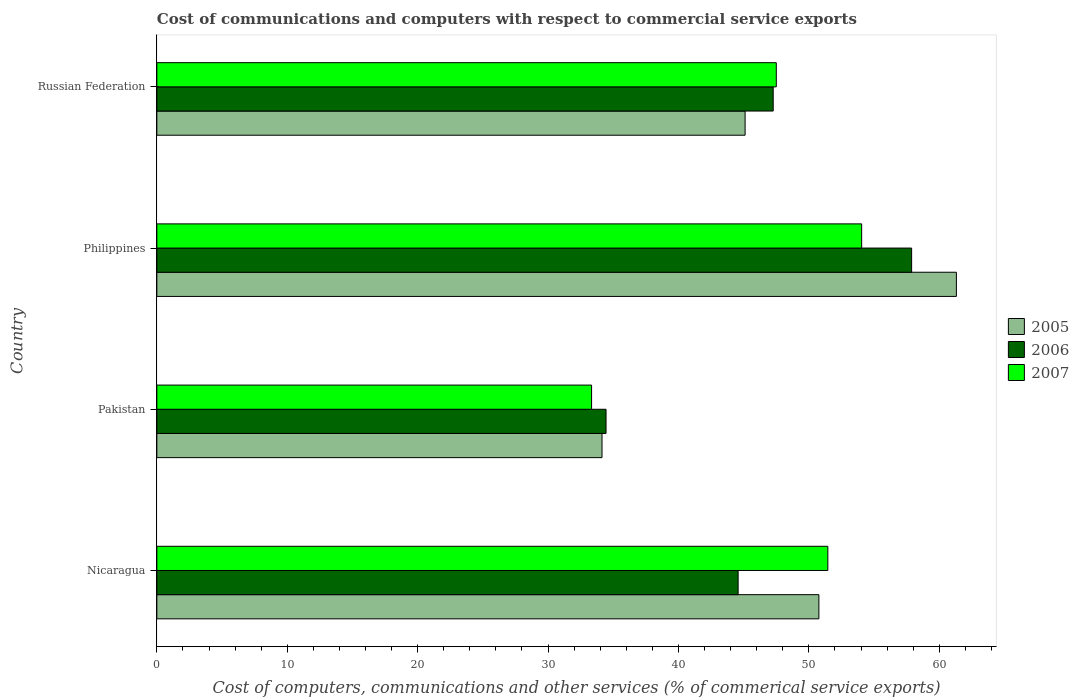How many different coloured bars are there?
Give a very brief answer. 3. How many groups of bars are there?
Your answer should be very brief. 4. Are the number of bars per tick equal to the number of legend labels?
Your response must be concise. Yes. How many bars are there on the 2nd tick from the top?
Offer a terse response. 3. What is the label of the 4th group of bars from the top?
Your answer should be very brief. Nicaragua. In how many cases, is the number of bars for a given country not equal to the number of legend labels?
Your response must be concise. 0. What is the cost of communications and computers in 2007 in Russian Federation?
Keep it short and to the point. 47.5. Across all countries, what is the maximum cost of communications and computers in 2005?
Your response must be concise. 61.31. Across all countries, what is the minimum cost of communications and computers in 2007?
Ensure brevity in your answer.  33.34. In which country was the cost of communications and computers in 2006 minimum?
Provide a short and direct response. Pakistan. What is the total cost of communications and computers in 2007 in the graph?
Give a very brief answer. 186.35. What is the difference between the cost of communications and computers in 2006 in Philippines and that in Russian Federation?
Provide a succinct answer. 10.62. What is the difference between the cost of communications and computers in 2007 in Nicaragua and the cost of communications and computers in 2006 in Pakistan?
Keep it short and to the point. 17.01. What is the average cost of communications and computers in 2006 per country?
Your answer should be very brief. 46.04. What is the difference between the cost of communications and computers in 2007 and cost of communications and computers in 2005 in Pakistan?
Provide a succinct answer. -0.8. What is the ratio of the cost of communications and computers in 2006 in Nicaragua to that in Russian Federation?
Ensure brevity in your answer.  0.94. Is the difference between the cost of communications and computers in 2007 in Pakistan and Philippines greater than the difference between the cost of communications and computers in 2005 in Pakistan and Philippines?
Offer a very short reply. Yes. What is the difference between the highest and the second highest cost of communications and computers in 2007?
Make the answer very short. 2.59. What is the difference between the highest and the lowest cost of communications and computers in 2007?
Provide a succinct answer. 20.71. In how many countries, is the cost of communications and computers in 2007 greater than the average cost of communications and computers in 2007 taken over all countries?
Offer a terse response. 3. Is it the case that in every country, the sum of the cost of communications and computers in 2007 and cost of communications and computers in 2005 is greater than the cost of communications and computers in 2006?
Make the answer very short. Yes. How many bars are there?
Give a very brief answer. 12. Are all the bars in the graph horizontal?
Offer a terse response. Yes. How many countries are there in the graph?
Provide a succinct answer. 4. What is the difference between two consecutive major ticks on the X-axis?
Ensure brevity in your answer.  10. Are the values on the major ticks of X-axis written in scientific E-notation?
Keep it short and to the point. No. Does the graph contain any zero values?
Offer a very short reply. No. Does the graph contain grids?
Offer a very short reply. No. How many legend labels are there?
Provide a succinct answer. 3. What is the title of the graph?
Make the answer very short. Cost of communications and computers with respect to commercial service exports. Does "1989" appear as one of the legend labels in the graph?
Your answer should be very brief. No. What is the label or title of the X-axis?
Offer a terse response. Cost of computers, communications and other services (% of commerical service exports). What is the label or title of the Y-axis?
Offer a very short reply. Country. What is the Cost of computers, communications and other services (% of commerical service exports) in 2005 in Nicaragua?
Your answer should be compact. 50.77. What is the Cost of computers, communications and other services (% of commerical service exports) in 2006 in Nicaragua?
Offer a terse response. 44.58. What is the Cost of computers, communications and other services (% of commerical service exports) of 2007 in Nicaragua?
Provide a succinct answer. 51.46. What is the Cost of computers, communications and other services (% of commerical service exports) of 2005 in Pakistan?
Your answer should be compact. 34.14. What is the Cost of computers, communications and other services (% of commerical service exports) in 2006 in Pakistan?
Your response must be concise. 34.45. What is the Cost of computers, communications and other services (% of commerical service exports) of 2007 in Pakistan?
Provide a short and direct response. 33.34. What is the Cost of computers, communications and other services (% of commerical service exports) in 2005 in Philippines?
Ensure brevity in your answer.  61.31. What is the Cost of computers, communications and other services (% of commerical service exports) of 2006 in Philippines?
Provide a succinct answer. 57.88. What is the Cost of computers, communications and other services (% of commerical service exports) of 2007 in Philippines?
Make the answer very short. 54.05. What is the Cost of computers, communications and other services (% of commerical service exports) of 2005 in Russian Federation?
Offer a very short reply. 45.11. What is the Cost of computers, communications and other services (% of commerical service exports) in 2006 in Russian Federation?
Make the answer very short. 47.27. What is the Cost of computers, communications and other services (% of commerical service exports) of 2007 in Russian Federation?
Provide a succinct answer. 47.5. Across all countries, what is the maximum Cost of computers, communications and other services (% of commerical service exports) in 2005?
Provide a short and direct response. 61.31. Across all countries, what is the maximum Cost of computers, communications and other services (% of commerical service exports) of 2006?
Make the answer very short. 57.88. Across all countries, what is the maximum Cost of computers, communications and other services (% of commerical service exports) of 2007?
Provide a succinct answer. 54.05. Across all countries, what is the minimum Cost of computers, communications and other services (% of commerical service exports) in 2005?
Give a very brief answer. 34.14. Across all countries, what is the minimum Cost of computers, communications and other services (% of commerical service exports) of 2006?
Ensure brevity in your answer.  34.45. Across all countries, what is the minimum Cost of computers, communications and other services (% of commerical service exports) of 2007?
Give a very brief answer. 33.34. What is the total Cost of computers, communications and other services (% of commerical service exports) of 2005 in the graph?
Offer a terse response. 191.33. What is the total Cost of computers, communications and other services (% of commerical service exports) of 2006 in the graph?
Offer a terse response. 184.17. What is the total Cost of computers, communications and other services (% of commerical service exports) of 2007 in the graph?
Offer a very short reply. 186.35. What is the difference between the Cost of computers, communications and other services (% of commerical service exports) in 2005 in Nicaragua and that in Pakistan?
Offer a terse response. 16.63. What is the difference between the Cost of computers, communications and other services (% of commerical service exports) in 2006 in Nicaragua and that in Pakistan?
Provide a short and direct response. 10.13. What is the difference between the Cost of computers, communications and other services (% of commerical service exports) in 2007 in Nicaragua and that in Pakistan?
Offer a very short reply. 18.12. What is the difference between the Cost of computers, communications and other services (% of commerical service exports) of 2005 in Nicaragua and that in Philippines?
Provide a short and direct response. -10.54. What is the difference between the Cost of computers, communications and other services (% of commerical service exports) in 2006 in Nicaragua and that in Philippines?
Your answer should be compact. -13.31. What is the difference between the Cost of computers, communications and other services (% of commerical service exports) of 2007 in Nicaragua and that in Philippines?
Offer a very short reply. -2.59. What is the difference between the Cost of computers, communications and other services (% of commerical service exports) in 2005 in Nicaragua and that in Russian Federation?
Give a very brief answer. 5.66. What is the difference between the Cost of computers, communications and other services (% of commerical service exports) of 2006 in Nicaragua and that in Russian Federation?
Give a very brief answer. -2.69. What is the difference between the Cost of computers, communications and other services (% of commerical service exports) of 2007 in Nicaragua and that in Russian Federation?
Your answer should be very brief. 3.95. What is the difference between the Cost of computers, communications and other services (% of commerical service exports) of 2005 in Pakistan and that in Philippines?
Provide a succinct answer. -27.18. What is the difference between the Cost of computers, communications and other services (% of commerical service exports) in 2006 in Pakistan and that in Philippines?
Your answer should be compact. -23.43. What is the difference between the Cost of computers, communications and other services (% of commerical service exports) of 2007 in Pakistan and that in Philippines?
Your response must be concise. -20.71. What is the difference between the Cost of computers, communications and other services (% of commerical service exports) in 2005 in Pakistan and that in Russian Federation?
Your response must be concise. -10.97. What is the difference between the Cost of computers, communications and other services (% of commerical service exports) in 2006 in Pakistan and that in Russian Federation?
Your answer should be compact. -12.82. What is the difference between the Cost of computers, communications and other services (% of commerical service exports) of 2007 in Pakistan and that in Russian Federation?
Offer a terse response. -14.17. What is the difference between the Cost of computers, communications and other services (% of commerical service exports) of 2005 in Philippines and that in Russian Federation?
Provide a succinct answer. 16.2. What is the difference between the Cost of computers, communications and other services (% of commerical service exports) in 2006 in Philippines and that in Russian Federation?
Your response must be concise. 10.62. What is the difference between the Cost of computers, communications and other services (% of commerical service exports) in 2007 in Philippines and that in Russian Federation?
Your answer should be very brief. 6.54. What is the difference between the Cost of computers, communications and other services (% of commerical service exports) in 2005 in Nicaragua and the Cost of computers, communications and other services (% of commerical service exports) in 2006 in Pakistan?
Your answer should be very brief. 16.32. What is the difference between the Cost of computers, communications and other services (% of commerical service exports) in 2005 in Nicaragua and the Cost of computers, communications and other services (% of commerical service exports) in 2007 in Pakistan?
Keep it short and to the point. 17.43. What is the difference between the Cost of computers, communications and other services (% of commerical service exports) of 2006 in Nicaragua and the Cost of computers, communications and other services (% of commerical service exports) of 2007 in Pakistan?
Keep it short and to the point. 11.24. What is the difference between the Cost of computers, communications and other services (% of commerical service exports) of 2005 in Nicaragua and the Cost of computers, communications and other services (% of commerical service exports) of 2006 in Philippines?
Your answer should be very brief. -7.11. What is the difference between the Cost of computers, communications and other services (% of commerical service exports) of 2005 in Nicaragua and the Cost of computers, communications and other services (% of commerical service exports) of 2007 in Philippines?
Ensure brevity in your answer.  -3.28. What is the difference between the Cost of computers, communications and other services (% of commerical service exports) of 2006 in Nicaragua and the Cost of computers, communications and other services (% of commerical service exports) of 2007 in Philippines?
Ensure brevity in your answer.  -9.47. What is the difference between the Cost of computers, communications and other services (% of commerical service exports) of 2005 in Nicaragua and the Cost of computers, communications and other services (% of commerical service exports) of 2006 in Russian Federation?
Offer a very short reply. 3.5. What is the difference between the Cost of computers, communications and other services (% of commerical service exports) of 2005 in Nicaragua and the Cost of computers, communications and other services (% of commerical service exports) of 2007 in Russian Federation?
Offer a terse response. 3.27. What is the difference between the Cost of computers, communications and other services (% of commerical service exports) in 2006 in Nicaragua and the Cost of computers, communications and other services (% of commerical service exports) in 2007 in Russian Federation?
Provide a short and direct response. -2.93. What is the difference between the Cost of computers, communications and other services (% of commerical service exports) of 2005 in Pakistan and the Cost of computers, communications and other services (% of commerical service exports) of 2006 in Philippines?
Keep it short and to the point. -23.74. What is the difference between the Cost of computers, communications and other services (% of commerical service exports) of 2005 in Pakistan and the Cost of computers, communications and other services (% of commerical service exports) of 2007 in Philippines?
Your answer should be compact. -19.91. What is the difference between the Cost of computers, communications and other services (% of commerical service exports) in 2006 in Pakistan and the Cost of computers, communications and other services (% of commerical service exports) in 2007 in Philippines?
Make the answer very short. -19.6. What is the difference between the Cost of computers, communications and other services (% of commerical service exports) of 2005 in Pakistan and the Cost of computers, communications and other services (% of commerical service exports) of 2006 in Russian Federation?
Give a very brief answer. -13.13. What is the difference between the Cost of computers, communications and other services (% of commerical service exports) in 2005 in Pakistan and the Cost of computers, communications and other services (% of commerical service exports) in 2007 in Russian Federation?
Your answer should be very brief. -13.37. What is the difference between the Cost of computers, communications and other services (% of commerical service exports) of 2006 in Pakistan and the Cost of computers, communications and other services (% of commerical service exports) of 2007 in Russian Federation?
Your answer should be compact. -13.06. What is the difference between the Cost of computers, communications and other services (% of commerical service exports) in 2005 in Philippines and the Cost of computers, communications and other services (% of commerical service exports) in 2006 in Russian Federation?
Ensure brevity in your answer.  14.05. What is the difference between the Cost of computers, communications and other services (% of commerical service exports) of 2005 in Philippines and the Cost of computers, communications and other services (% of commerical service exports) of 2007 in Russian Federation?
Offer a very short reply. 13.81. What is the difference between the Cost of computers, communications and other services (% of commerical service exports) of 2006 in Philippines and the Cost of computers, communications and other services (% of commerical service exports) of 2007 in Russian Federation?
Provide a succinct answer. 10.38. What is the average Cost of computers, communications and other services (% of commerical service exports) of 2005 per country?
Your answer should be compact. 47.83. What is the average Cost of computers, communications and other services (% of commerical service exports) of 2006 per country?
Make the answer very short. 46.04. What is the average Cost of computers, communications and other services (% of commerical service exports) in 2007 per country?
Ensure brevity in your answer.  46.59. What is the difference between the Cost of computers, communications and other services (% of commerical service exports) of 2005 and Cost of computers, communications and other services (% of commerical service exports) of 2006 in Nicaragua?
Provide a short and direct response. 6.19. What is the difference between the Cost of computers, communications and other services (% of commerical service exports) in 2005 and Cost of computers, communications and other services (% of commerical service exports) in 2007 in Nicaragua?
Offer a very short reply. -0.68. What is the difference between the Cost of computers, communications and other services (% of commerical service exports) in 2006 and Cost of computers, communications and other services (% of commerical service exports) in 2007 in Nicaragua?
Keep it short and to the point. -6.88. What is the difference between the Cost of computers, communications and other services (% of commerical service exports) of 2005 and Cost of computers, communications and other services (% of commerical service exports) of 2006 in Pakistan?
Give a very brief answer. -0.31. What is the difference between the Cost of computers, communications and other services (% of commerical service exports) of 2005 and Cost of computers, communications and other services (% of commerical service exports) of 2007 in Pakistan?
Your response must be concise. 0.8. What is the difference between the Cost of computers, communications and other services (% of commerical service exports) in 2006 and Cost of computers, communications and other services (% of commerical service exports) in 2007 in Pakistan?
Offer a very short reply. 1.11. What is the difference between the Cost of computers, communications and other services (% of commerical service exports) in 2005 and Cost of computers, communications and other services (% of commerical service exports) in 2006 in Philippines?
Your response must be concise. 3.43. What is the difference between the Cost of computers, communications and other services (% of commerical service exports) in 2005 and Cost of computers, communications and other services (% of commerical service exports) in 2007 in Philippines?
Your answer should be compact. 7.27. What is the difference between the Cost of computers, communications and other services (% of commerical service exports) of 2006 and Cost of computers, communications and other services (% of commerical service exports) of 2007 in Philippines?
Keep it short and to the point. 3.83. What is the difference between the Cost of computers, communications and other services (% of commerical service exports) in 2005 and Cost of computers, communications and other services (% of commerical service exports) in 2006 in Russian Federation?
Make the answer very short. -2.15. What is the difference between the Cost of computers, communications and other services (% of commerical service exports) in 2005 and Cost of computers, communications and other services (% of commerical service exports) in 2007 in Russian Federation?
Give a very brief answer. -2.39. What is the difference between the Cost of computers, communications and other services (% of commerical service exports) in 2006 and Cost of computers, communications and other services (% of commerical service exports) in 2007 in Russian Federation?
Offer a very short reply. -0.24. What is the ratio of the Cost of computers, communications and other services (% of commerical service exports) in 2005 in Nicaragua to that in Pakistan?
Offer a very short reply. 1.49. What is the ratio of the Cost of computers, communications and other services (% of commerical service exports) in 2006 in Nicaragua to that in Pakistan?
Provide a succinct answer. 1.29. What is the ratio of the Cost of computers, communications and other services (% of commerical service exports) in 2007 in Nicaragua to that in Pakistan?
Your answer should be very brief. 1.54. What is the ratio of the Cost of computers, communications and other services (% of commerical service exports) in 2005 in Nicaragua to that in Philippines?
Give a very brief answer. 0.83. What is the ratio of the Cost of computers, communications and other services (% of commerical service exports) in 2006 in Nicaragua to that in Philippines?
Make the answer very short. 0.77. What is the ratio of the Cost of computers, communications and other services (% of commerical service exports) in 2005 in Nicaragua to that in Russian Federation?
Offer a terse response. 1.13. What is the ratio of the Cost of computers, communications and other services (% of commerical service exports) in 2006 in Nicaragua to that in Russian Federation?
Make the answer very short. 0.94. What is the ratio of the Cost of computers, communications and other services (% of commerical service exports) in 2007 in Nicaragua to that in Russian Federation?
Offer a terse response. 1.08. What is the ratio of the Cost of computers, communications and other services (% of commerical service exports) of 2005 in Pakistan to that in Philippines?
Your answer should be very brief. 0.56. What is the ratio of the Cost of computers, communications and other services (% of commerical service exports) of 2006 in Pakistan to that in Philippines?
Provide a short and direct response. 0.6. What is the ratio of the Cost of computers, communications and other services (% of commerical service exports) in 2007 in Pakistan to that in Philippines?
Your response must be concise. 0.62. What is the ratio of the Cost of computers, communications and other services (% of commerical service exports) in 2005 in Pakistan to that in Russian Federation?
Your answer should be very brief. 0.76. What is the ratio of the Cost of computers, communications and other services (% of commerical service exports) in 2006 in Pakistan to that in Russian Federation?
Your answer should be very brief. 0.73. What is the ratio of the Cost of computers, communications and other services (% of commerical service exports) of 2007 in Pakistan to that in Russian Federation?
Keep it short and to the point. 0.7. What is the ratio of the Cost of computers, communications and other services (% of commerical service exports) in 2005 in Philippines to that in Russian Federation?
Your response must be concise. 1.36. What is the ratio of the Cost of computers, communications and other services (% of commerical service exports) of 2006 in Philippines to that in Russian Federation?
Offer a very short reply. 1.22. What is the ratio of the Cost of computers, communications and other services (% of commerical service exports) of 2007 in Philippines to that in Russian Federation?
Provide a short and direct response. 1.14. What is the difference between the highest and the second highest Cost of computers, communications and other services (% of commerical service exports) in 2005?
Offer a very short reply. 10.54. What is the difference between the highest and the second highest Cost of computers, communications and other services (% of commerical service exports) in 2006?
Provide a succinct answer. 10.62. What is the difference between the highest and the second highest Cost of computers, communications and other services (% of commerical service exports) of 2007?
Give a very brief answer. 2.59. What is the difference between the highest and the lowest Cost of computers, communications and other services (% of commerical service exports) in 2005?
Give a very brief answer. 27.18. What is the difference between the highest and the lowest Cost of computers, communications and other services (% of commerical service exports) of 2006?
Provide a short and direct response. 23.43. What is the difference between the highest and the lowest Cost of computers, communications and other services (% of commerical service exports) of 2007?
Provide a short and direct response. 20.71. 